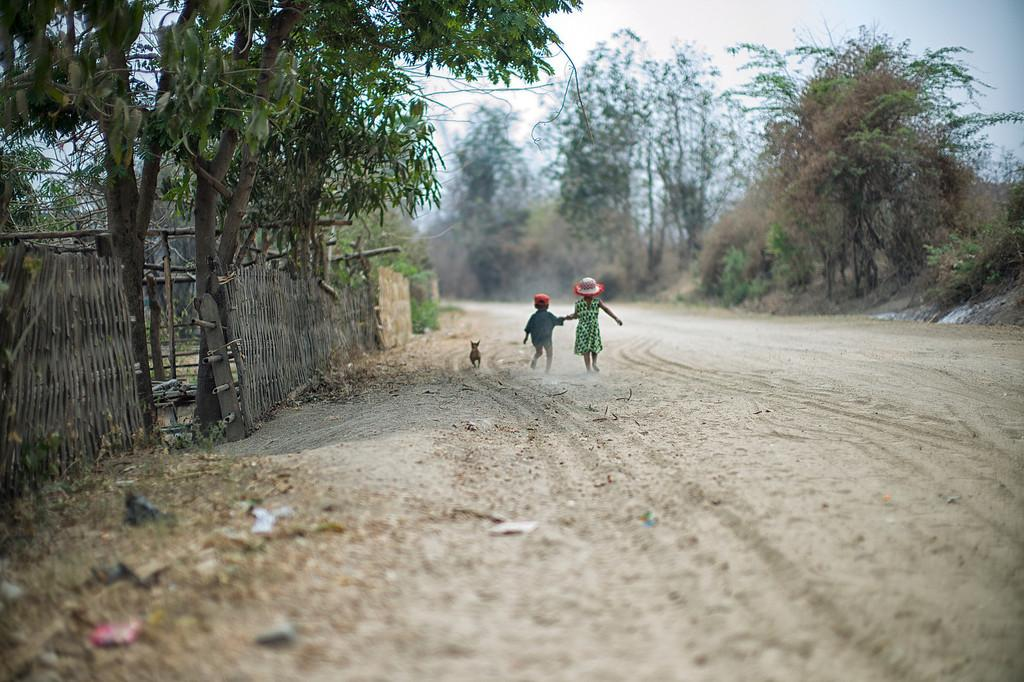How many kids are present in the image? There are two kids on the ground in the image. What is located beside the kids? There is an animal beside the kids. What can be seen in the background of the image? There are trees, a fence, and the sky visible in the background of the image. What type of shop can be seen in the background of the image? There is no shop present in the image; it features two kids on the ground, an animal beside them, and a background with trees, a fence, and the sky. 